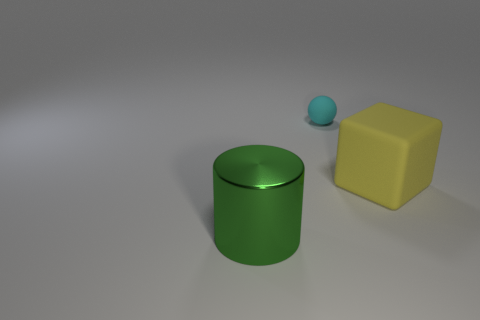Add 3 yellow metal balls. How many objects exist? 6 Subtract all cubes. How many objects are left? 2 Subtract all big yellow rubber things. Subtract all large blue shiny cylinders. How many objects are left? 2 Add 3 large objects. How many large objects are left? 5 Add 1 small red metallic balls. How many small red metallic balls exist? 1 Subtract 0 brown cubes. How many objects are left? 3 